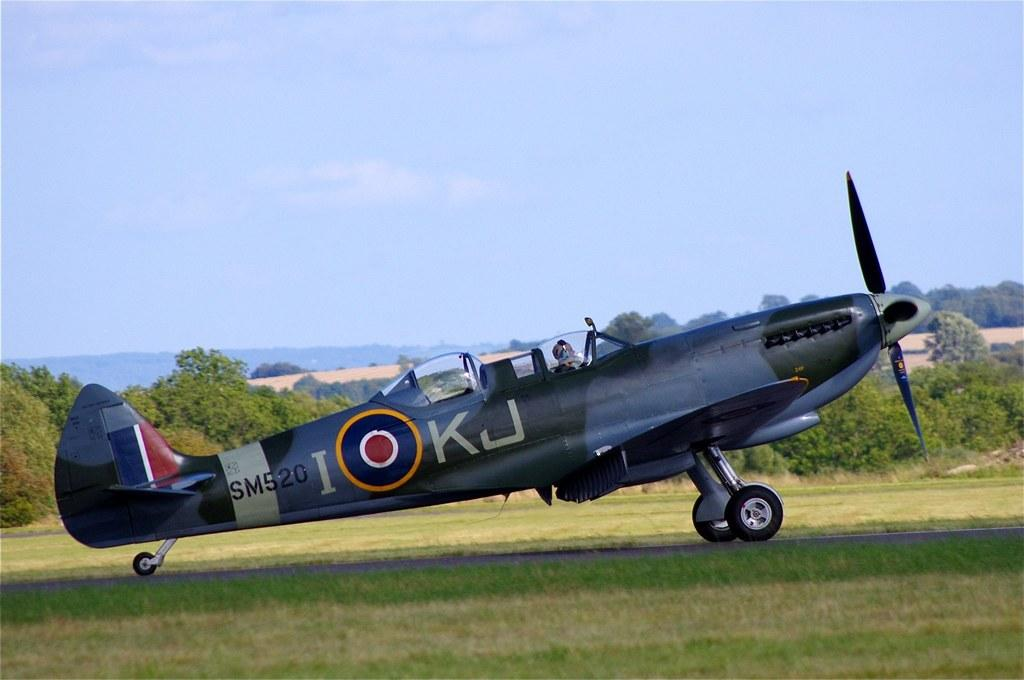What is the main subject of the image? The main subject of the image is an airplane on the runway. Can you describe the person in the image? There is a person in the image, but their specific appearance or actions are not mentioned in the facts. What type of natural environment is visible in the image? Trees, hills, and grass are visible in the image, indicating a natural environment. What is visible in the sky in the image? The sky is visible in the image, but no specific weather or celestial bodies are mentioned. What type of cable is being used by the beginner in the image? There is no mention of a cable or a beginner in the image, so this question cannot be answered. 